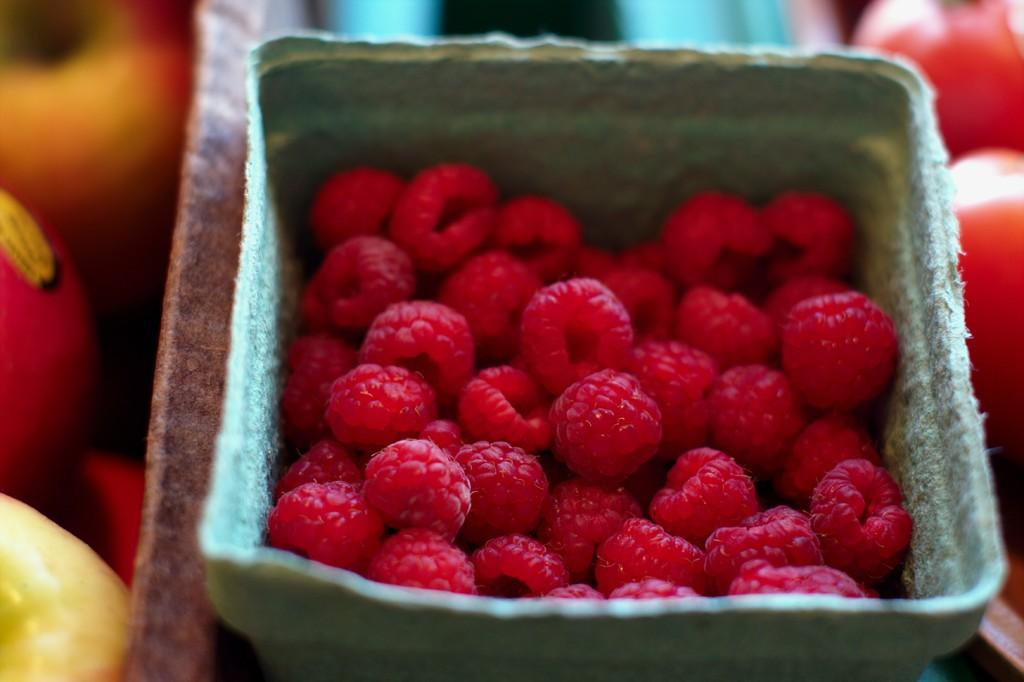What is the main subject of the image? The main subject of the image is food. Where is the food located in the image? The food is in the center of the image. What type of silver items can be seen in the image? There is no silver item present in the image. What experience can be gained from observing the food in the image? The image does not convey any specific experience; it simply shows food in the center. 